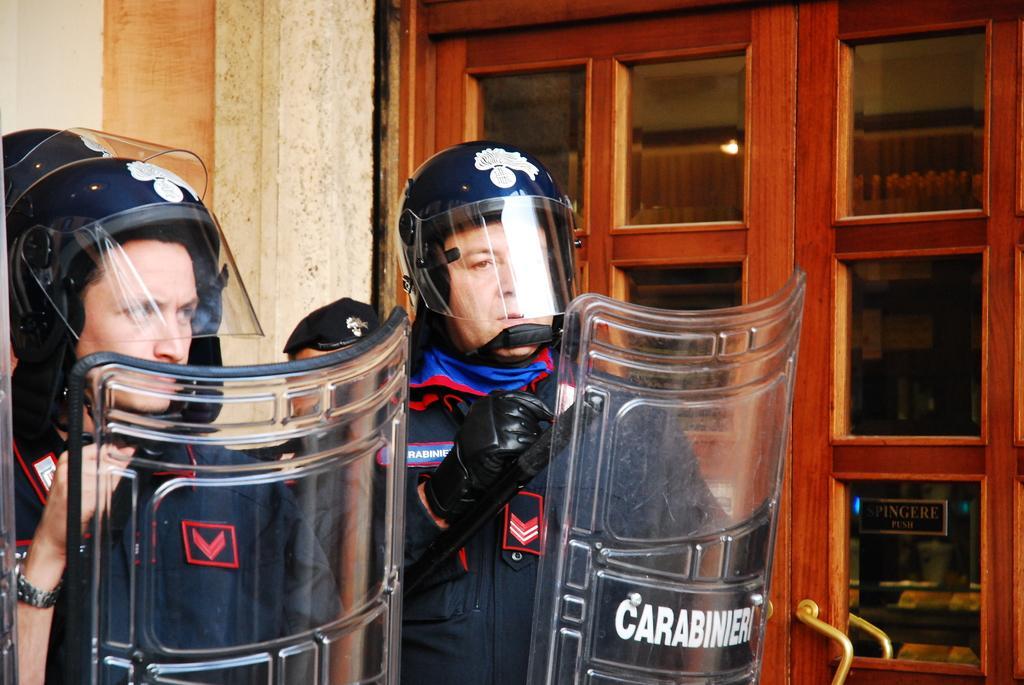In one or two sentences, can you explain what this image depicts? In this image we can see two persons wearing uniforms, helmets and holding shield in their hands. In the background, we can see the wooden glass doors and the wall. 